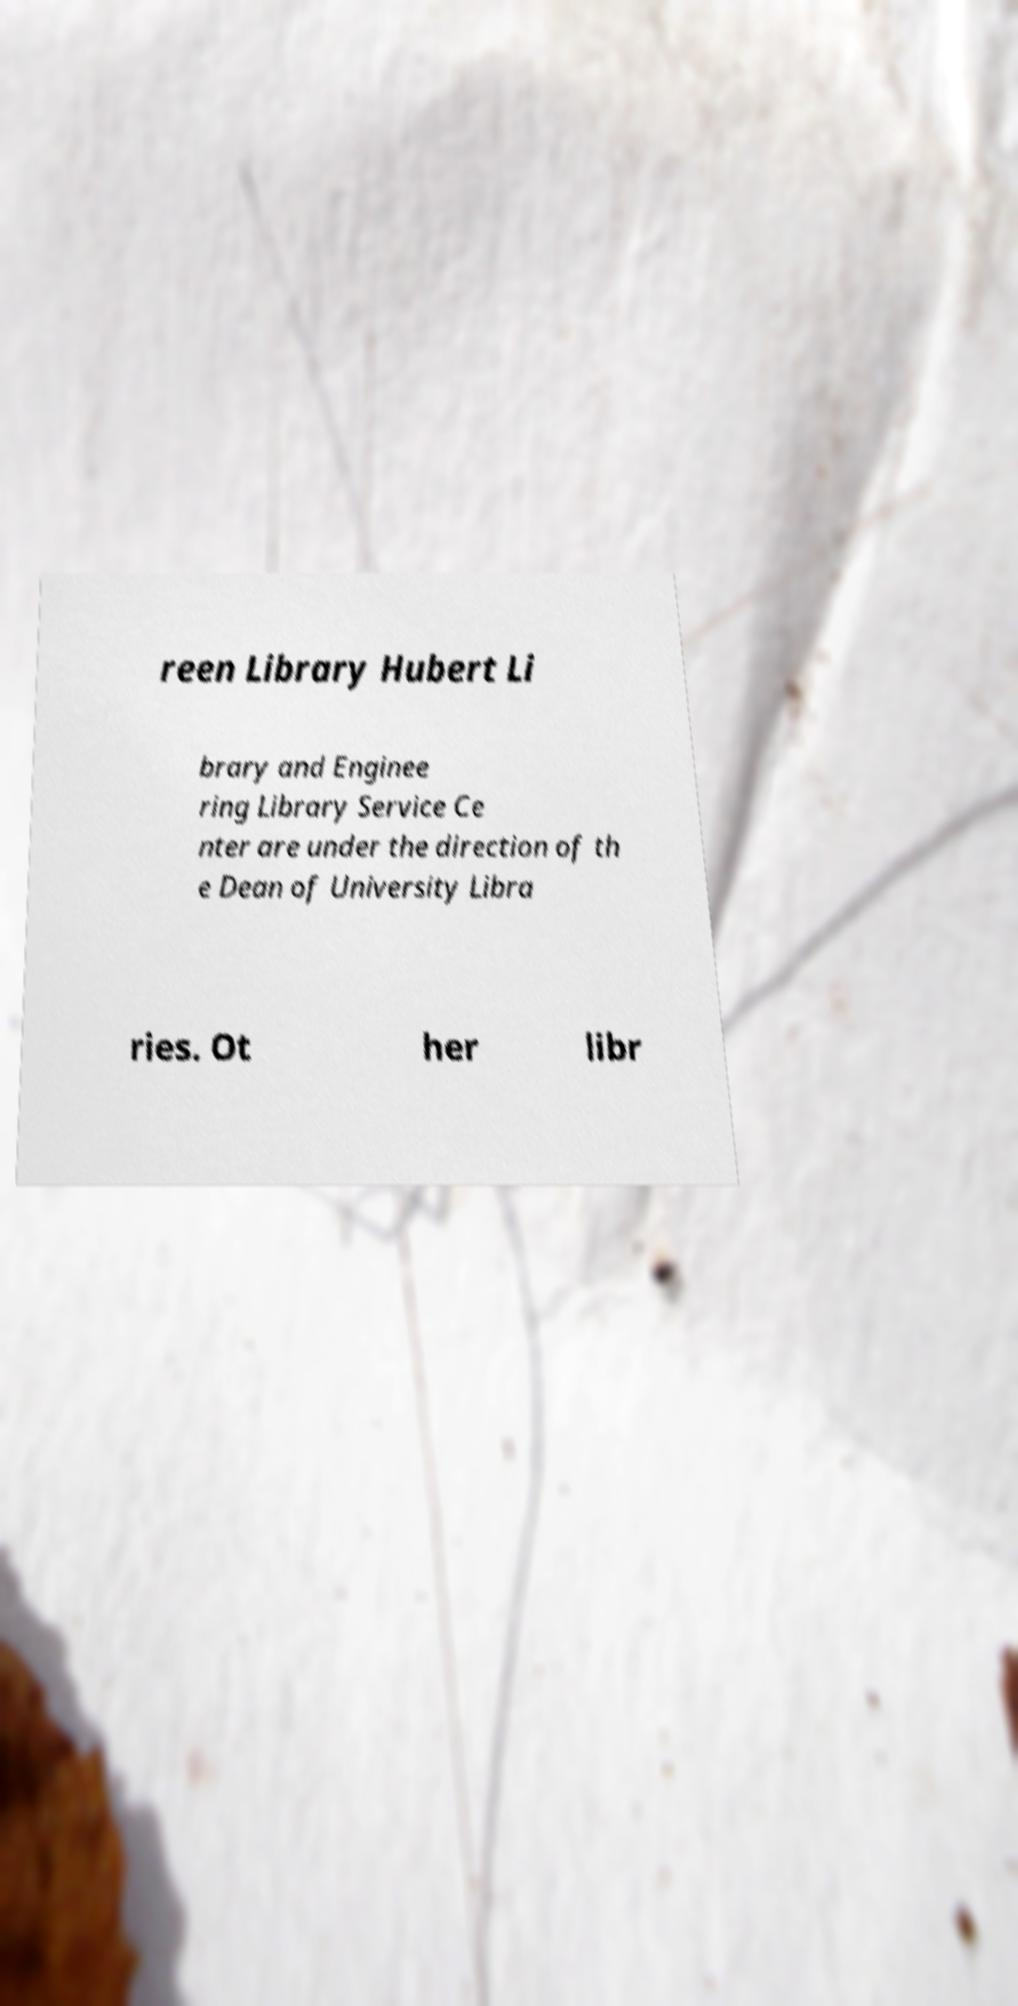What messages or text are displayed in this image? I need them in a readable, typed format. reen Library Hubert Li brary and Enginee ring Library Service Ce nter are under the direction of th e Dean of University Libra ries. Ot her libr 